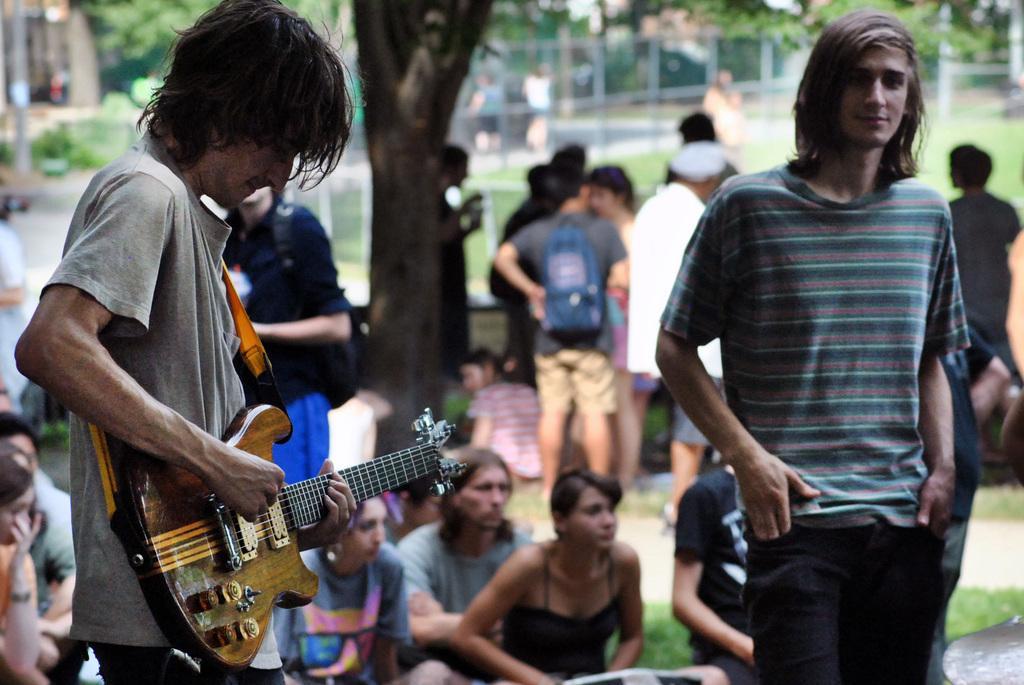In one or two sentences, can you explain what this image depicts? in this image i can see a group persons standing and some persons sitting on the floor an back ground i can see a there are some trees. And right side a person wearing a checked shirt standing on the right side and there is a person on left side holding a guitar and standing on left side. 